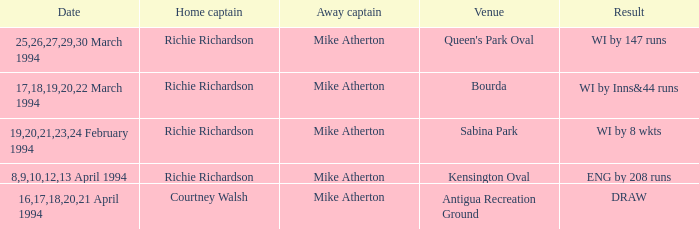What is the result of Courtney Walsh ? DRAW. 